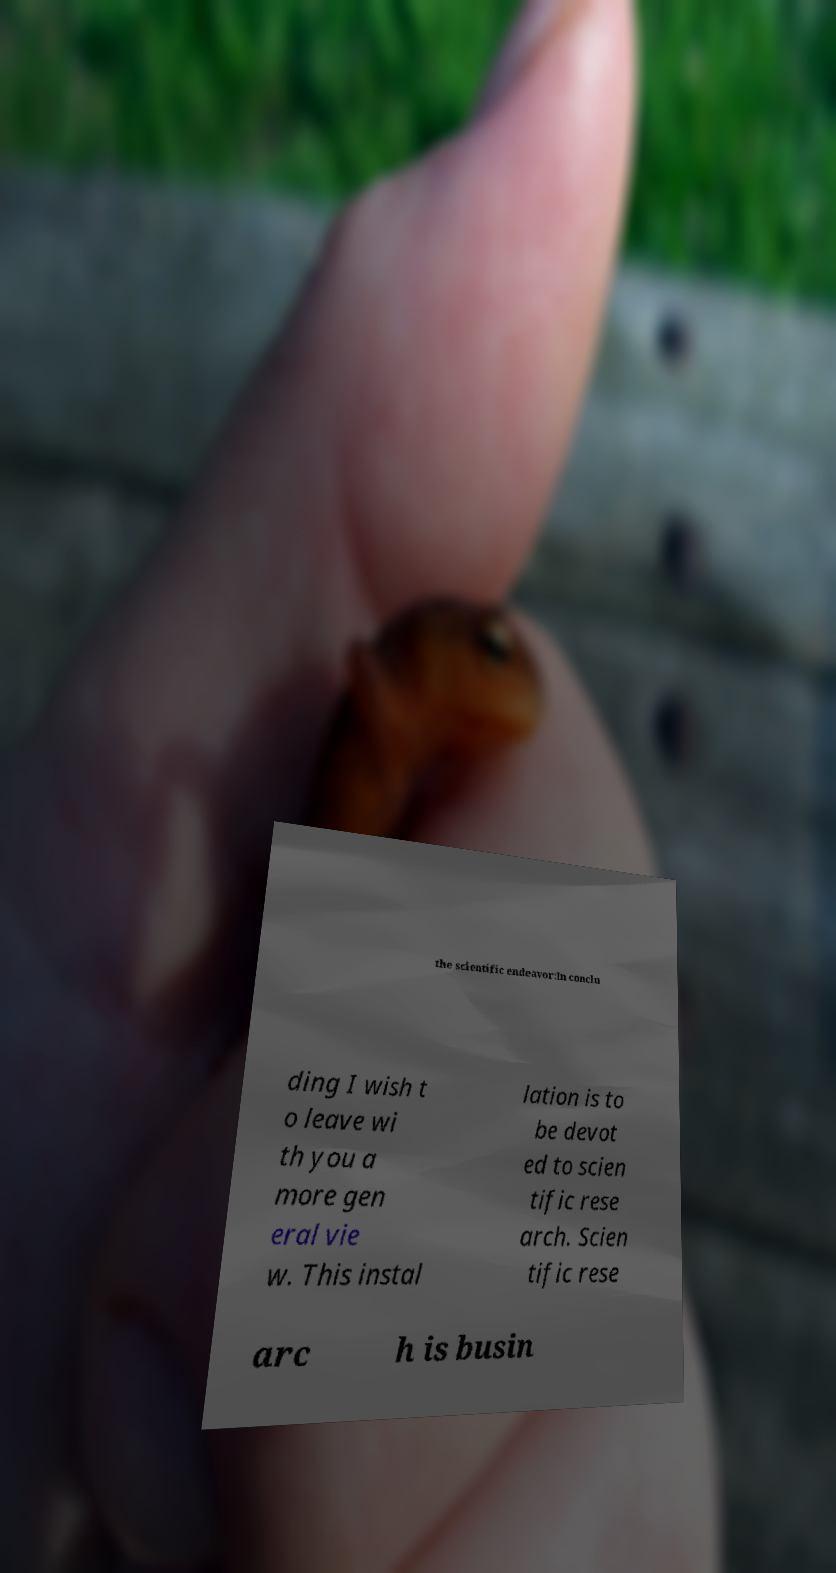What messages or text are displayed in this image? I need them in a readable, typed format. the scientific endeavor:In conclu ding I wish t o leave wi th you a more gen eral vie w. This instal lation is to be devot ed to scien tific rese arch. Scien tific rese arc h is busin 